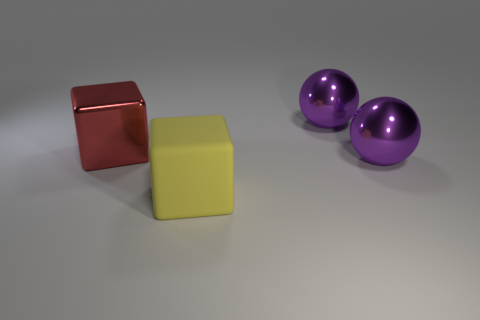The big rubber object is what color?
Offer a very short reply. Yellow. How many large objects are either purple shiny balls or cubes?
Offer a very short reply. 4. Is the number of big purple metal objects on the right side of the big red cube greater than the number of matte cubes that are on the left side of the large yellow object?
Provide a short and direct response. Yes. What color is the other thing that is the same shape as the red thing?
Your response must be concise. Yellow. The yellow block is what size?
Offer a very short reply. Large. The shiny thing in front of the thing that is to the left of the large yellow cube is what color?
Offer a very short reply. Purple. What number of things are in front of the red object and right of the yellow matte object?
Offer a very short reply. 1. Are there more red things than big green cubes?
Ensure brevity in your answer.  Yes. What is the big yellow object made of?
Your response must be concise. Rubber. There is a large thing that is to the left of the big yellow rubber block; how many metallic balls are behind it?
Offer a very short reply. 1. 